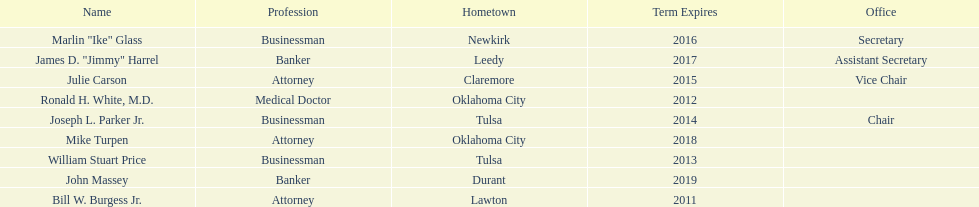Other members of the state regents from tulsa besides joseph l. parker jr. William Stuart Price. 